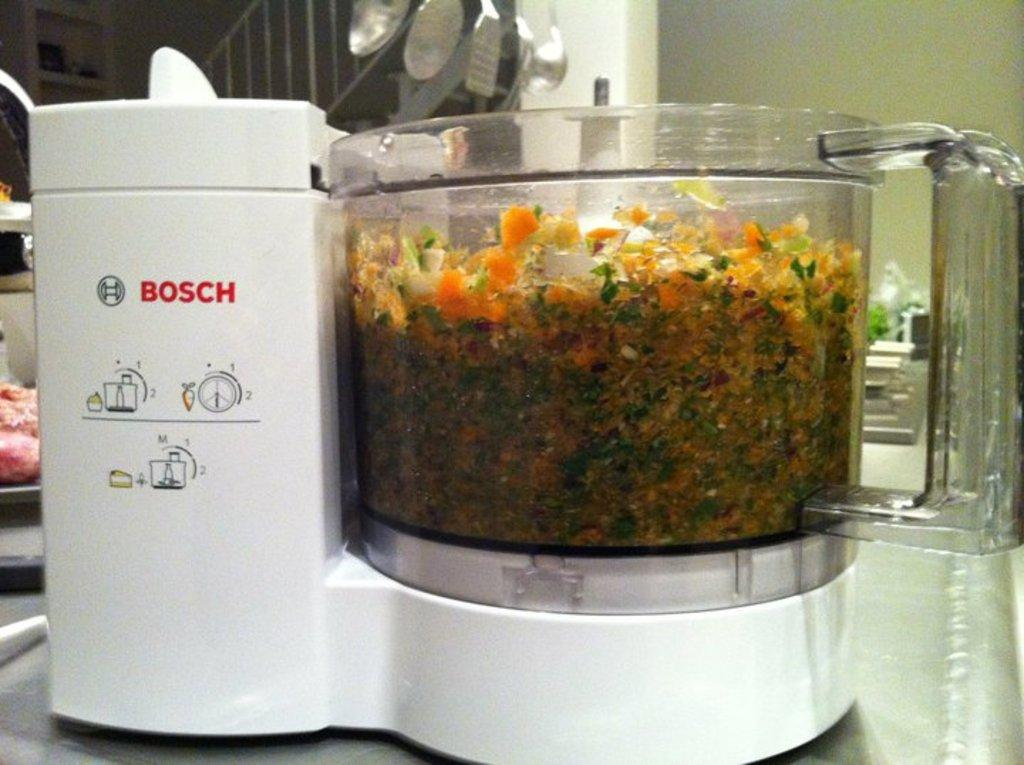<image>
Render a clear and concise summary of the photo. The Bosch food processor has some chopped up food in it. 